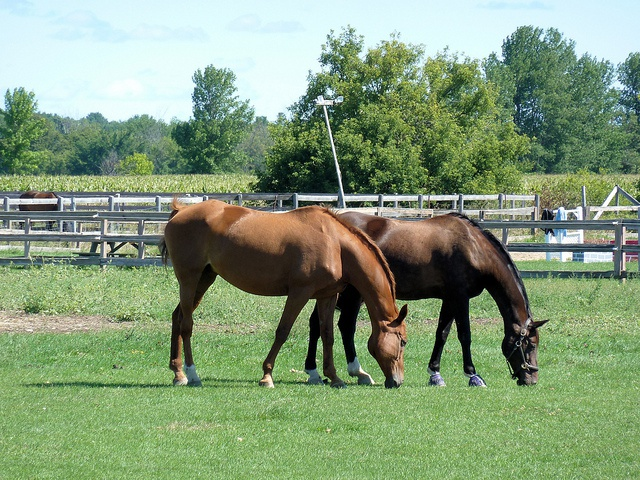Describe the objects in this image and their specific colors. I can see horse in lightblue, black, gray, and tan tones, horse in lightblue, black, gray, and maroon tones, and horse in lightblue, black, gray, maroon, and brown tones in this image. 